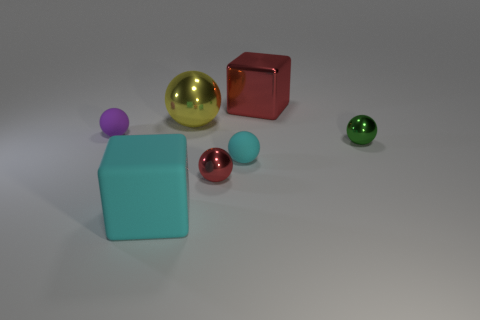Add 1 metallic balls. How many objects exist? 8 Add 7 yellow metal balls. How many yellow metal balls exist? 8 Subtract all red cubes. How many cubes are left? 1 Subtract all purple matte spheres. How many spheres are left? 4 Subtract 0 brown spheres. How many objects are left? 7 Subtract all blocks. How many objects are left? 5 Subtract 3 balls. How many balls are left? 2 Subtract all yellow spheres. Subtract all purple cylinders. How many spheres are left? 4 Subtract all gray blocks. How many gray balls are left? 0 Subtract all small green matte blocks. Subtract all tiny rubber objects. How many objects are left? 5 